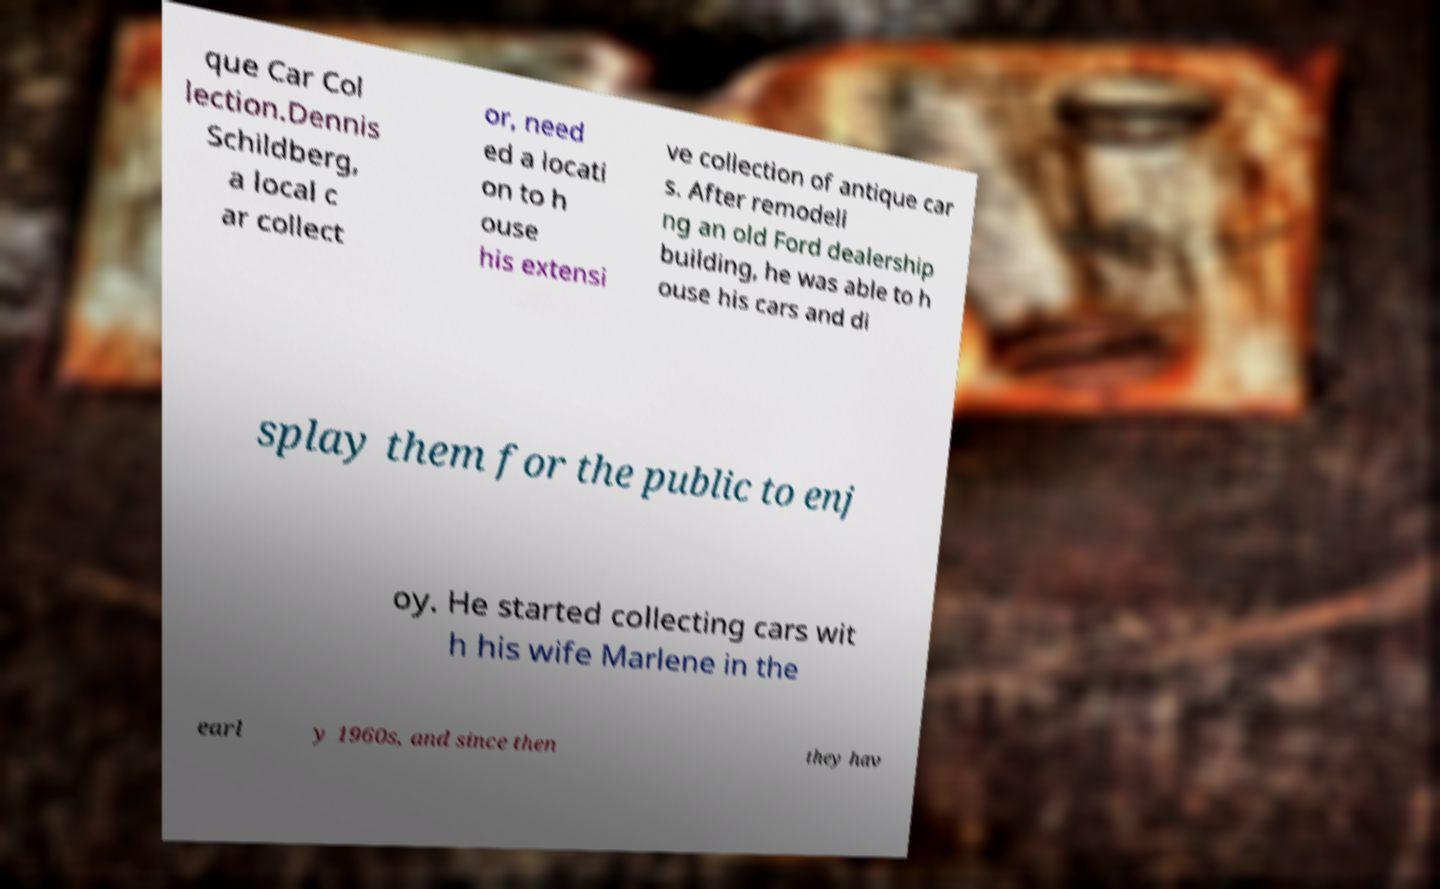Can you accurately transcribe the text from the provided image for me? que Car Col lection.Dennis Schildberg, a local c ar collect or, need ed a locati on to h ouse his extensi ve collection of antique car s. After remodeli ng an old Ford dealership building, he was able to h ouse his cars and di splay them for the public to enj oy. He started collecting cars wit h his wife Marlene in the earl y 1960s, and since then they hav 